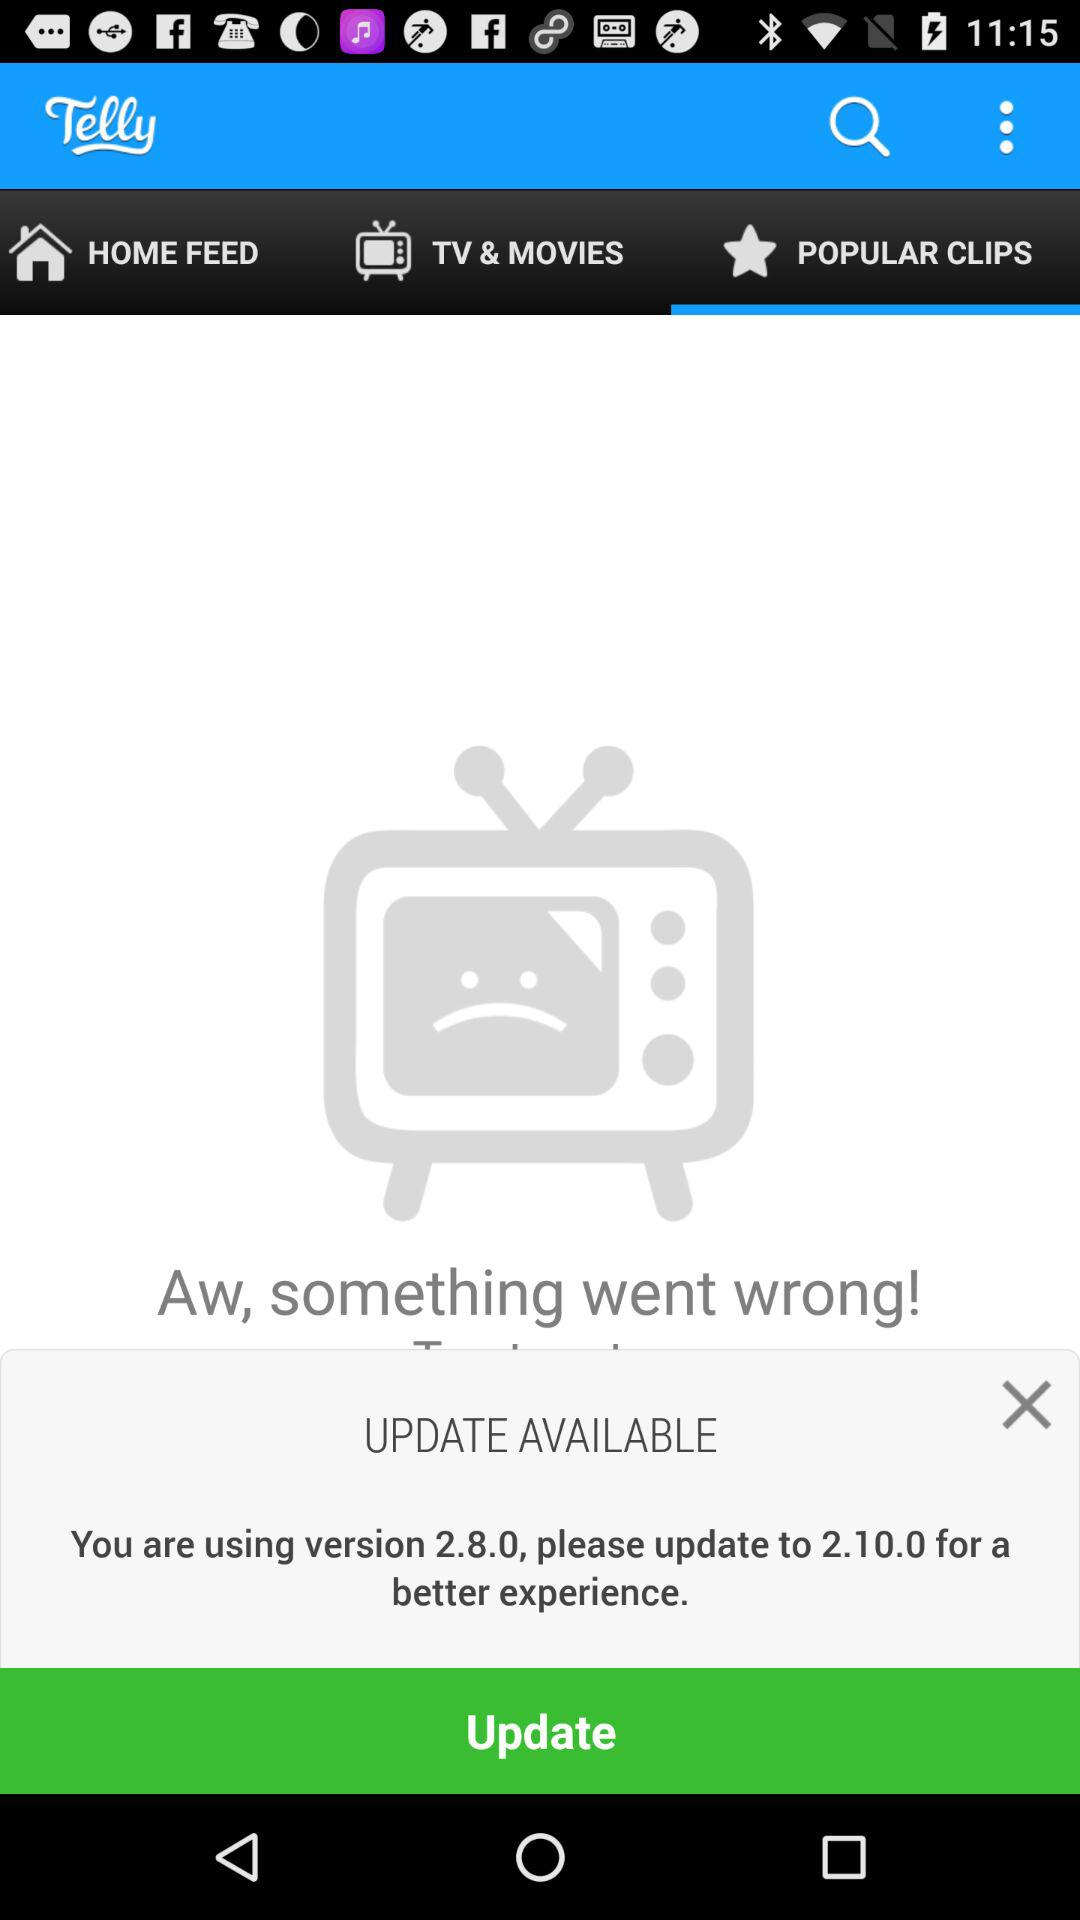Which tab is selected? The selected tab is "POPULAR CLIPS". 